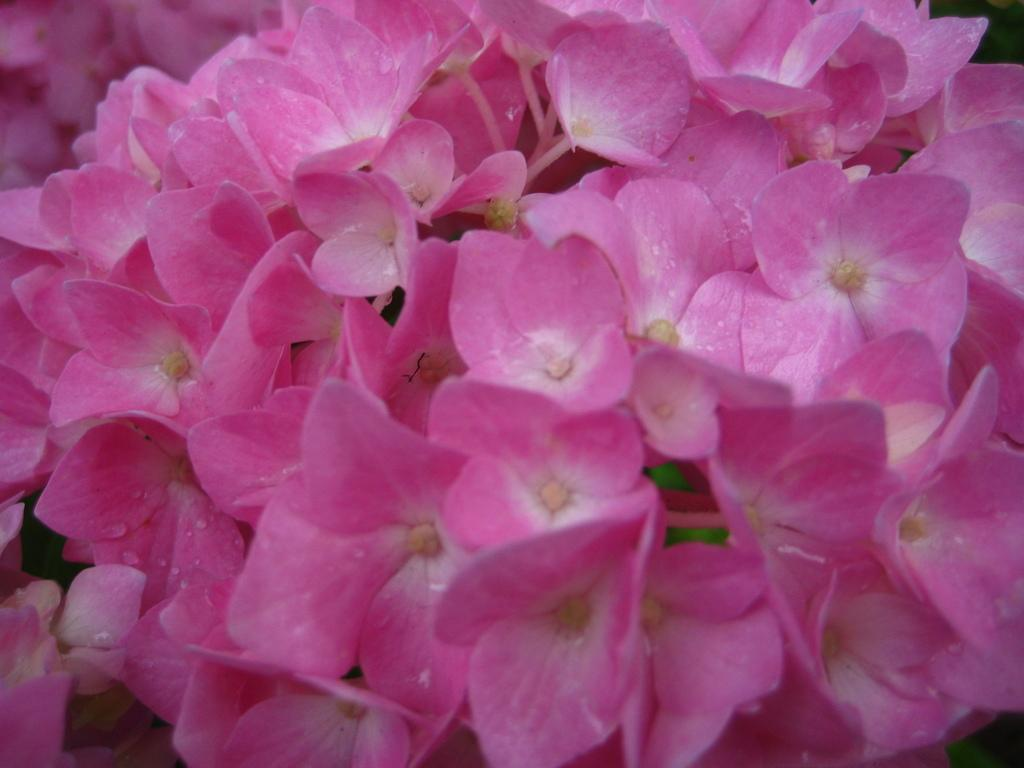What color are the flowers in the image? The flowers in the image are pink. What can be seen in the background of the image? The background of the image includes green leaves. Where can the jar of lettuce be found in the image? There is no jar of lettuce present in the image. 